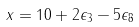Convert formula to latex. <formula><loc_0><loc_0><loc_500><loc_500>x = 1 0 + 2 \epsilon _ { 3 } - 5 \epsilon _ { 8 }</formula> 